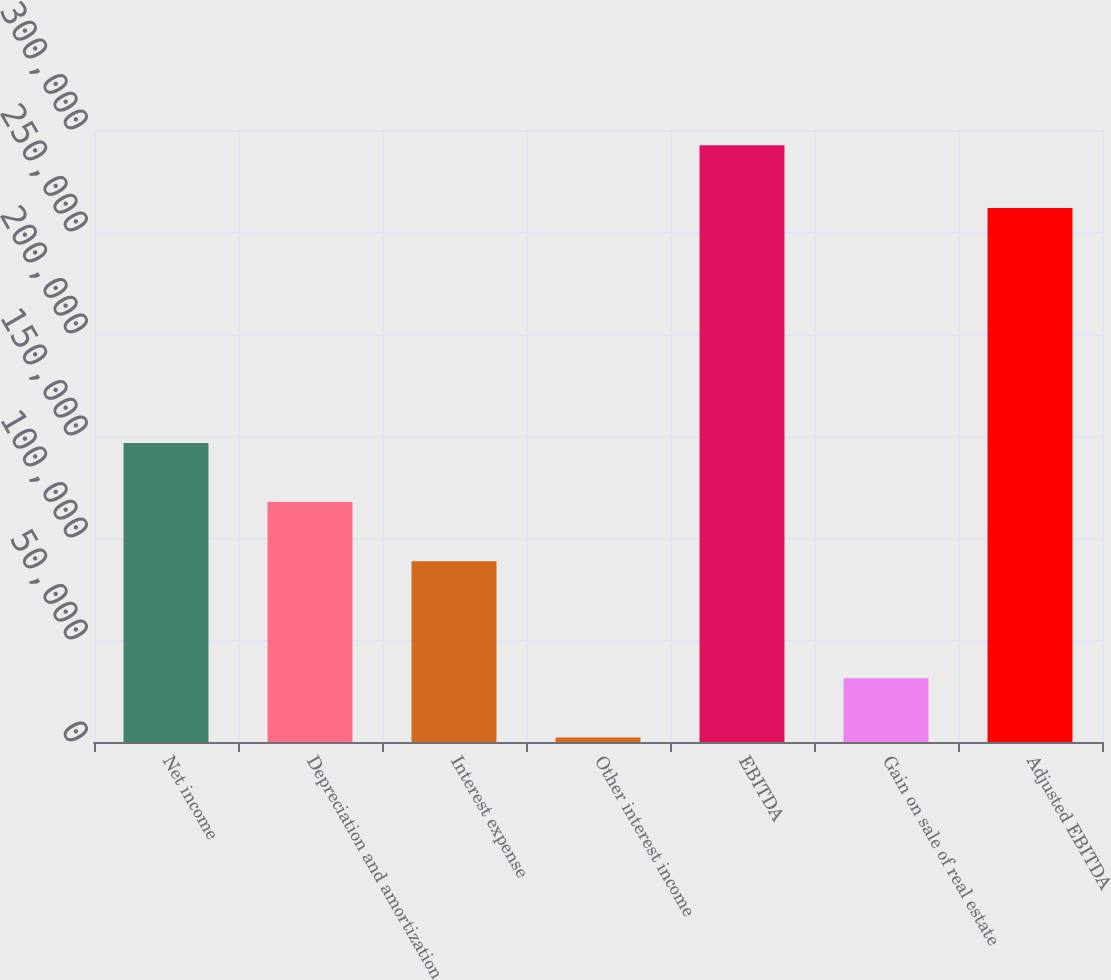Convert chart. <chart><loc_0><loc_0><loc_500><loc_500><bar_chart><fcel>Net income<fcel>Depreciation and amortization<fcel>Interest expense<fcel>Other interest income<fcel>EBITDA<fcel>Gain on sale of real estate<fcel>Adjusted EBITDA<nl><fcel>146616<fcel>117591<fcel>88566<fcel>2216<fcel>292465<fcel>31240.9<fcel>261717<nl></chart> 